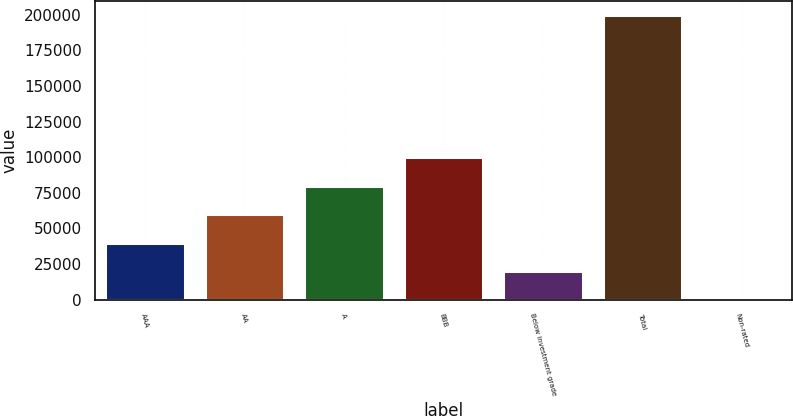<chart> <loc_0><loc_0><loc_500><loc_500><bar_chart><fcel>AAA<fcel>AA<fcel>A<fcel>BBB<fcel>Below investment grade<fcel>Total<fcel>Non-rated<nl><fcel>39959.2<fcel>59918.8<fcel>79878.4<fcel>99838<fcel>19999.6<fcel>199636<fcel>40<nl></chart> 